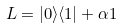Convert formula to latex. <formula><loc_0><loc_0><loc_500><loc_500>L = | 0 \rangle \langle 1 | + \alpha { 1 }</formula> 